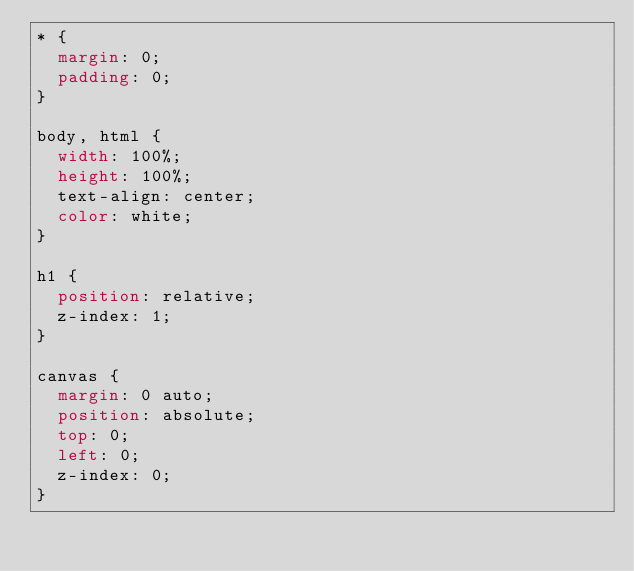Convert code to text. <code><loc_0><loc_0><loc_500><loc_500><_CSS_>* {
  margin: 0;
  padding: 0;
}

body, html {
  width: 100%;
  height: 100%;
  text-align: center;
  color: white;
}

h1 {
  position: relative;
  z-index: 1;
}

canvas {
  margin: 0 auto;
  position: absolute;
  top: 0;
  left: 0;
  z-index: 0;
}
</code> 